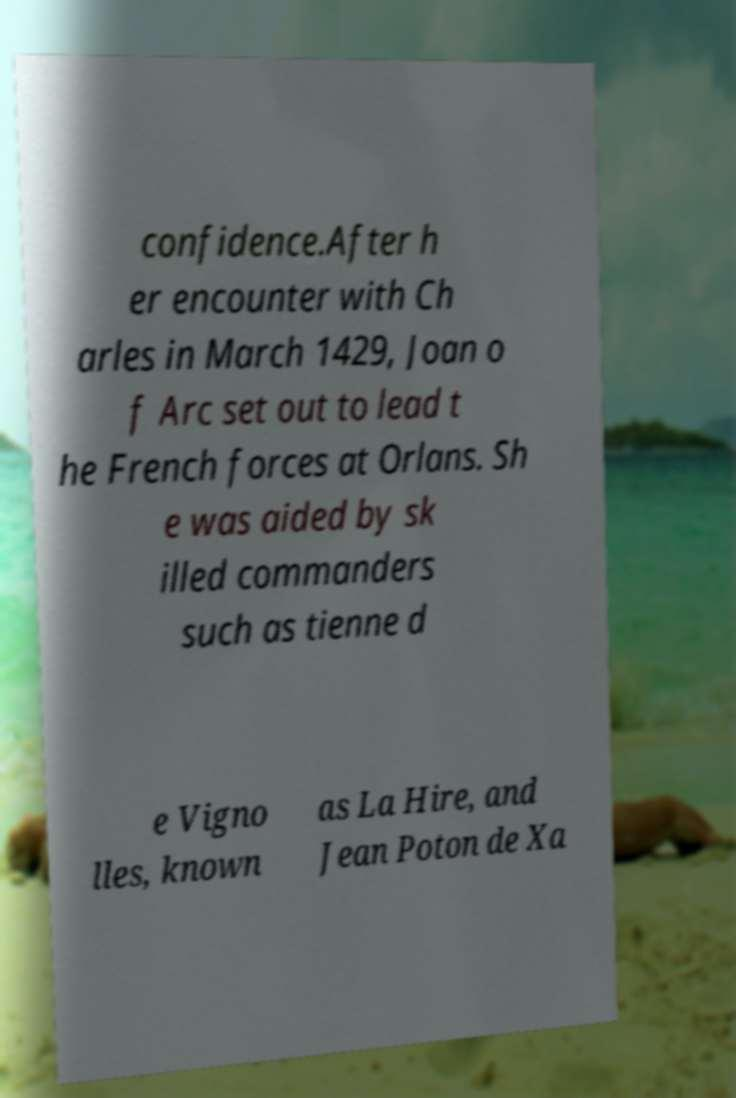There's text embedded in this image that I need extracted. Can you transcribe it verbatim? confidence.After h er encounter with Ch arles in March 1429, Joan o f Arc set out to lead t he French forces at Orlans. Sh e was aided by sk illed commanders such as tienne d e Vigno lles, known as La Hire, and Jean Poton de Xa 